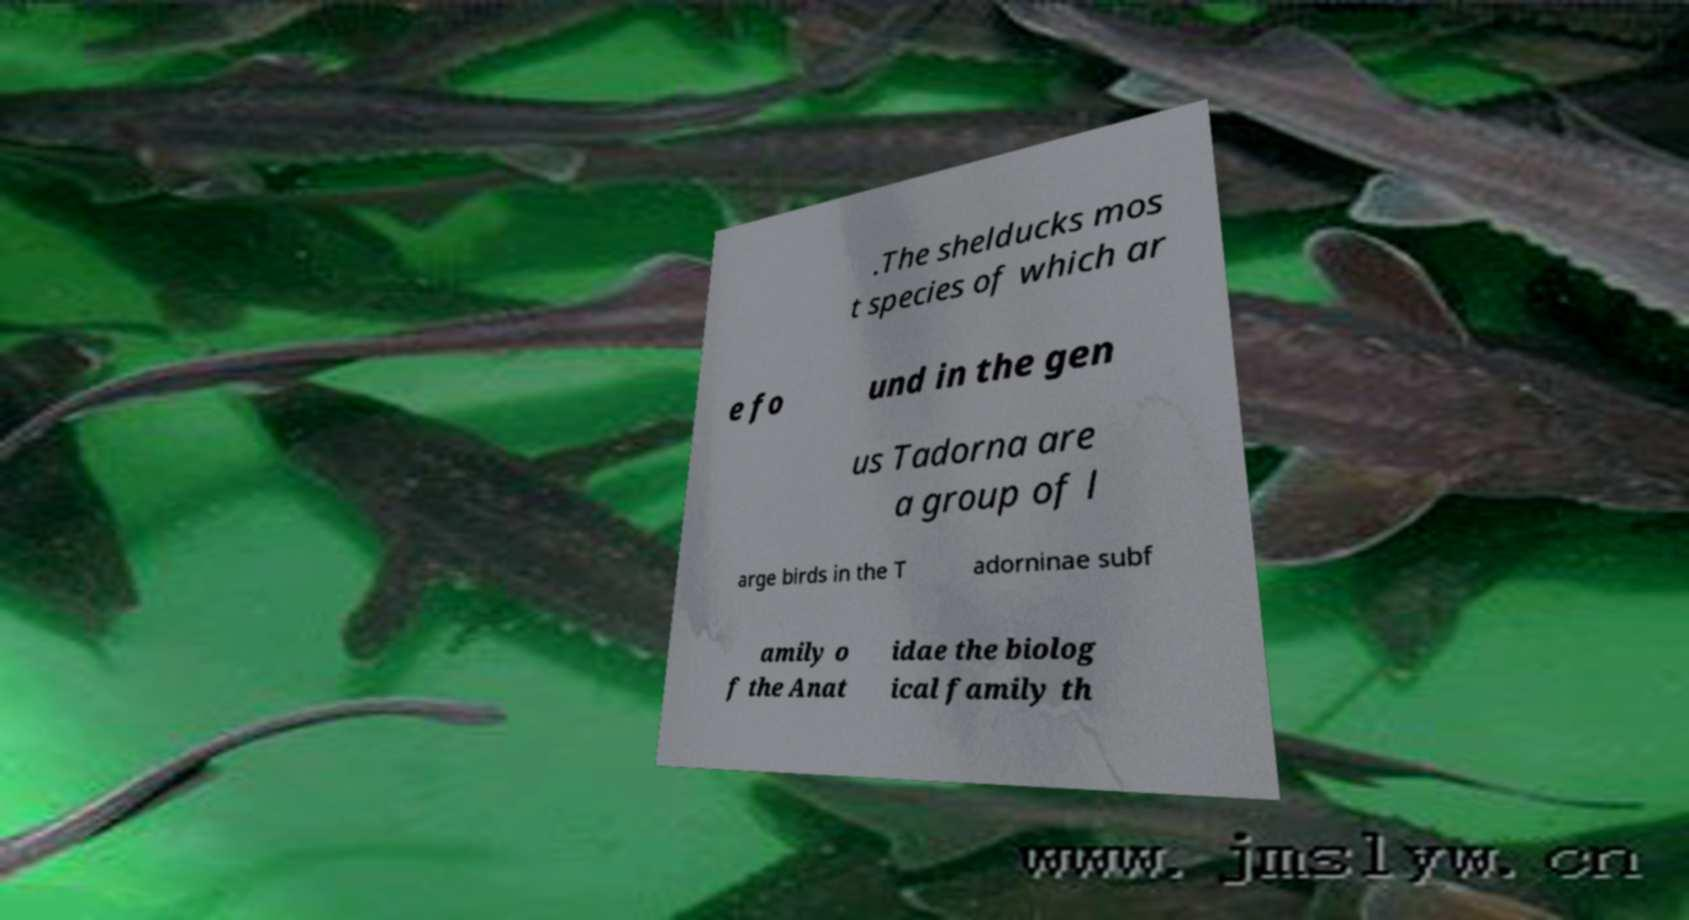Could you assist in decoding the text presented in this image and type it out clearly? .The shelducks mos t species of which ar e fo und in the gen us Tadorna are a group of l arge birds in the T adorninae subf amily o f the Anat idae the biolog ical family th 